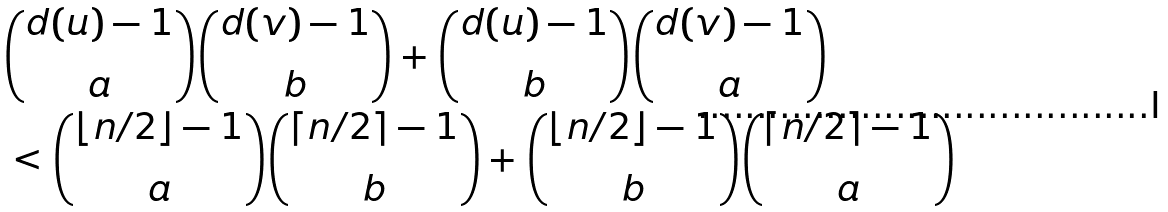Convert formula to latex. <formula><loc_0><loc_0><loc_500><loc_500>& \binom { d ( u ) - 1 } { a } \binom { d ( v ) - 1 } { b } + \binom { d ( u ) - 1 } { b } \binom { d ( v ) - 1 } { a } \\ & < \binom { \lfloor n / 2 \rfloor - 1 } { a } \binom { \lceil n / 2 \rceil - 1 } { b } + \binom { \lfloor n / 2 \rfloor - 1 } { b } \binom { \lceil n / 2 \rceil - 1 } { a }</formula> 